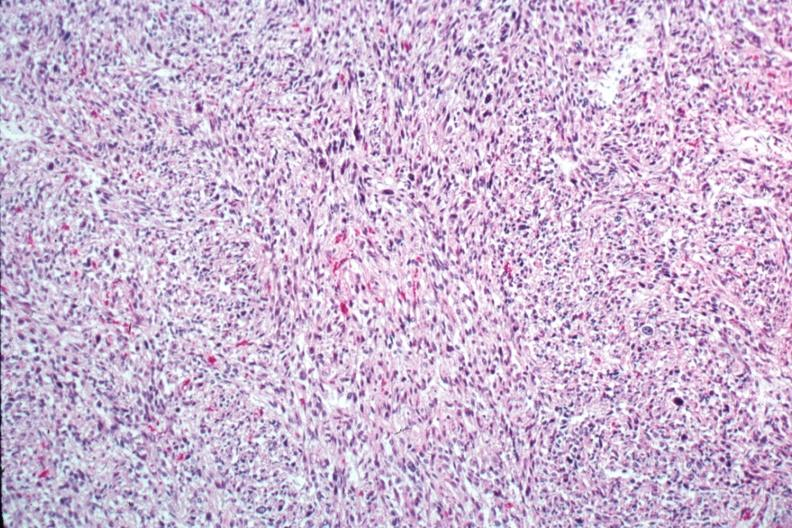what is present?
Answer the question using a single word or phrase. Uterus 